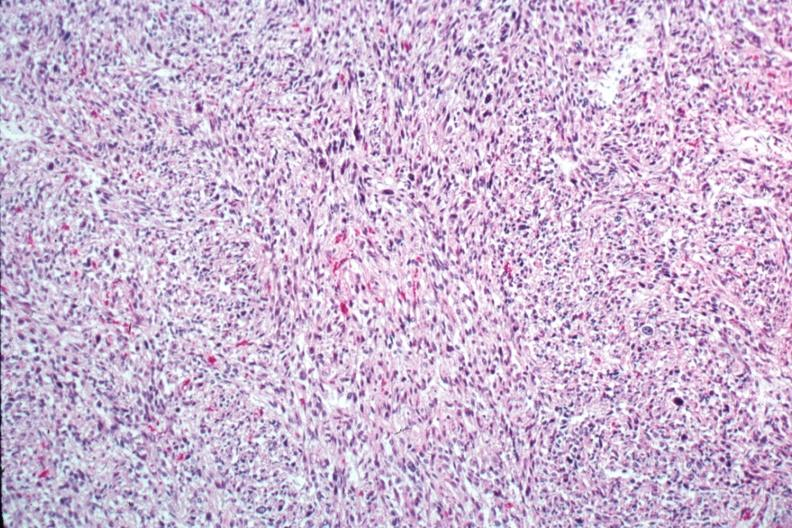what is present?
Answer the question using a single word or phrase. Uterus 